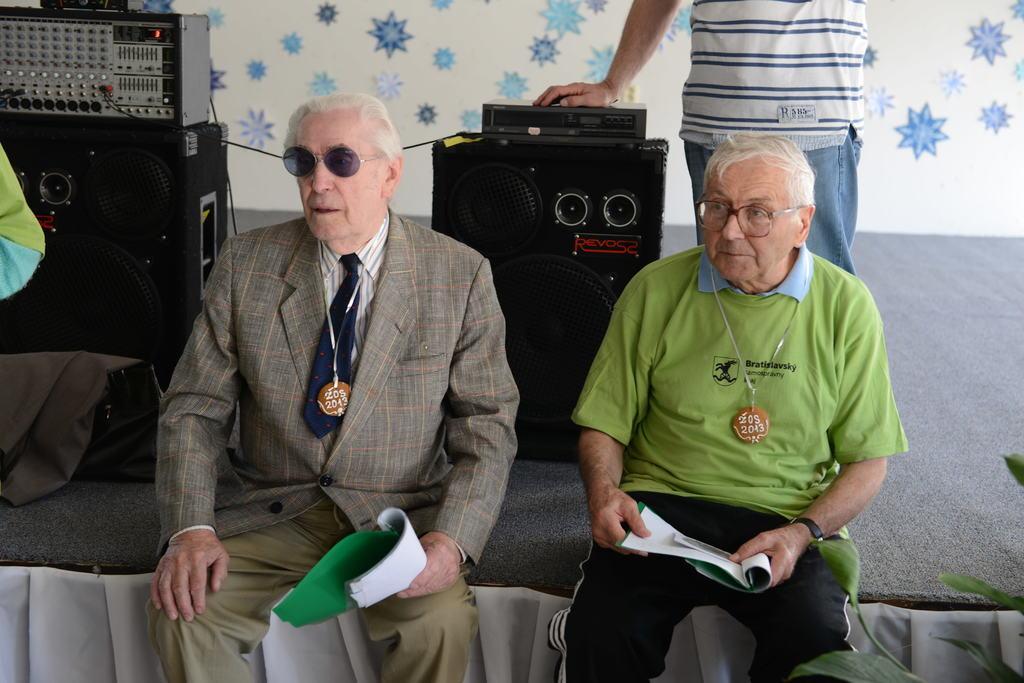How would you summarize this image in a sentence or two? In the image there are two old men sitting on stage with books in their hands and behind them there are speakers and a man standing in the middle in front of the wall. 